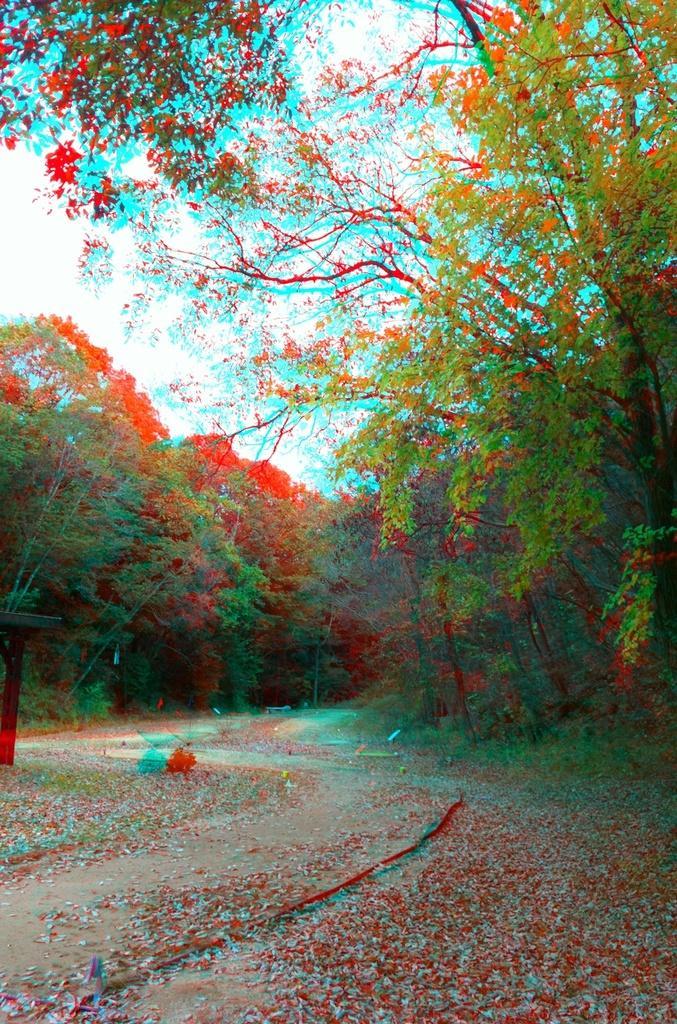In one or two sentences, can you explain what this image depicts? I see this is an edited image and in the picture I see number of trees and I see the path on which there are many leaves. In the background I see the sky. 